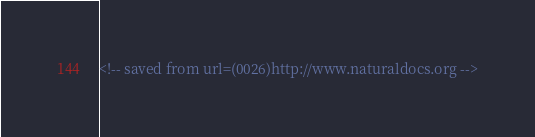Convert code to text. <code><loc_0><loc_0><loc_500><loc_500><_HTML_><!-- saved from url=(0026)http://www.naturaldocs.org -->



</code> 